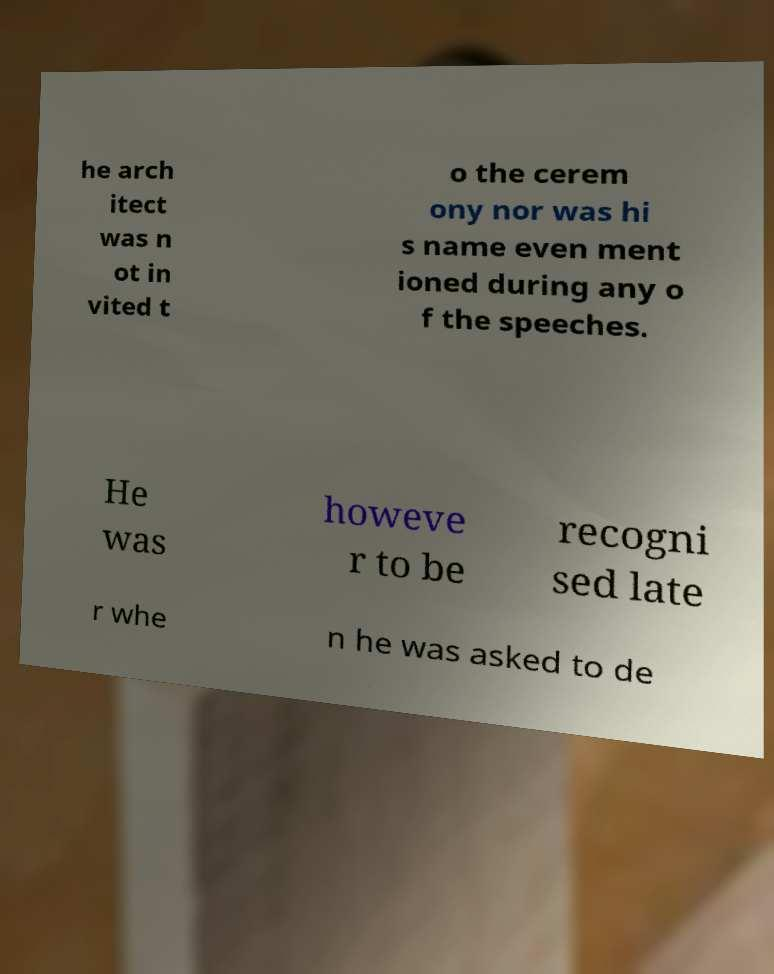Please read and relay the text visible in this image. What does it say? he arch itect was n ot in vited t o the cerem ony nor was hi s name even ment ioned during any o f the speeches. He was howeve r to be recogni sed late r whe n he was asked to de 